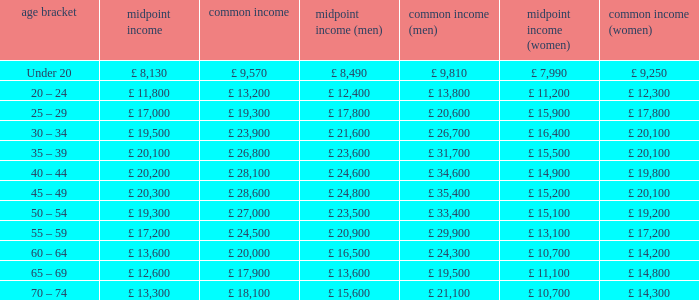Name the median income for age band being under 20 £ 8,130. 